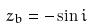<formula> <loc_0><loc_0><loc_500><loc_500>z _ { b } = - \sin i</formula> 